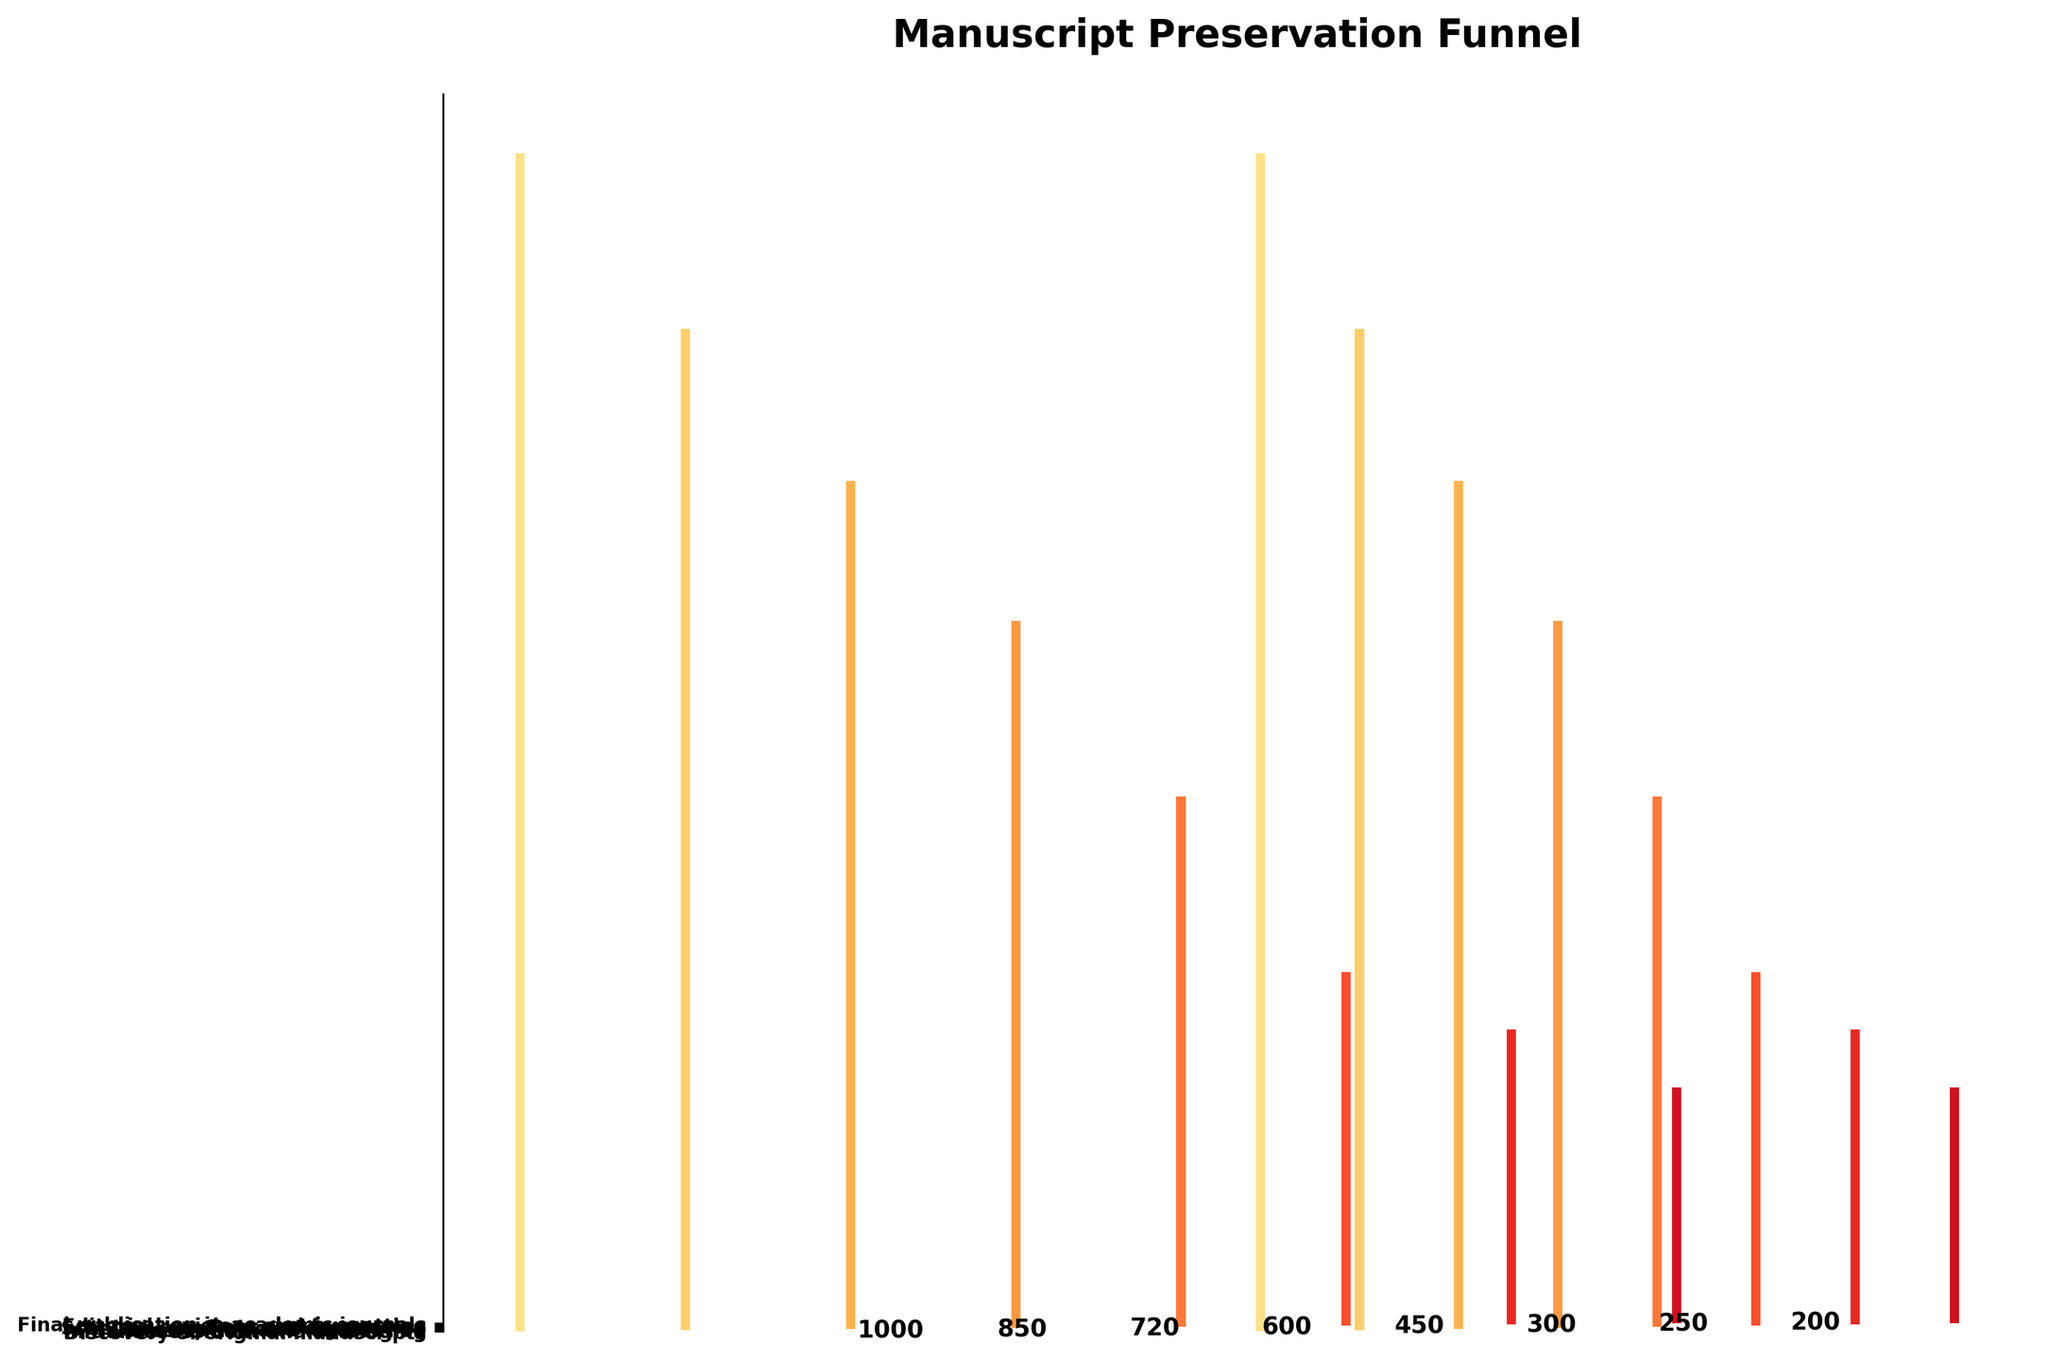Which stage retains the most manuscripts? The stage with the highest count of manuscripts is "Discovery of original manuscripts" with 1000 manuscripts.
Answer: Discovery of original manuscripts Which stage shows the greatest decrease in manuscripts from the previous stage? The largest decrease occurs between "Scholarly analysis and annotation" (450 manuscripts) and "Peer review process" (300 manuscripts), a decrease of 150 manuscripts.
Answer: Scholarly analysis and annotation to Peer review process How many manuscripts are lost between the "Discovery of original manuscripts" and the "Initial assessment and cataloging" stages? Subtract the number of manuscripts at the "Initial assessment and cataloging" stage (850) from the number at the "Discovery of original manuscripts" stage (1000): 1000 - 850 = 150 manuscripts lost.
Answer: 150 What is the total number of manuscripts lost from the "Discovery of original manuscripts" stage to the "Final publication in academic journals" stage? Start with 1000 manuscripts and reduce by each subsequent count: (1000 - 850 - 720 - 600 - 450 - 300 - 250 - 200) = 800 manuscripts lost in total.
Answer: 800 Which stage has the smallest number of manuscripts? The "Final publication in academic journals" stage has the smallest number with 200 manuscripts.
Answer: Final publication in academic journals How many stages have a decrease of more than 100 manuscripts? By examining each reduction: "Discovery of original manuscripts" to "Initial assessment and cataloging" (150), "Initial assessment and cataloging" to "Conservation and restoration" (130), "Conservation and restoration" to "Transcription and digitization" (120), "Transcription and digitization" to "Scholarly analysis and annotation" (150), "Scholarly analysis and annotation" to "Peer review process" (150). There are 5 stages with decreases of more than 100 manuscripts.
Answer: 5 Which transition stage has the closest number of manuscripts between stages? The smallest difference is between the "Peer review process" (300) and "Editorial revisions and formatting" (250) stages, a difference of 50 manuscripts.
Answer: Peer review process to Editorial revisions and formatting What is the average number of manuscripts across all stages? Sum all manuscript numbers: 1000 + 850 + 720 + 600 + 450 + 300 + 250 + 200 = 4370. Divide by the number of stages (8): 4370 / 8 = 546.25 manuscripts on average.
Answer: 546.25 What percentage of the original manuscripts reach the final publication stage? The final publication stage has 200 manuscripts out of the initial 1000. To find the percentage: (200 / 1000) x 100 = 20%.
Answer: 20% 